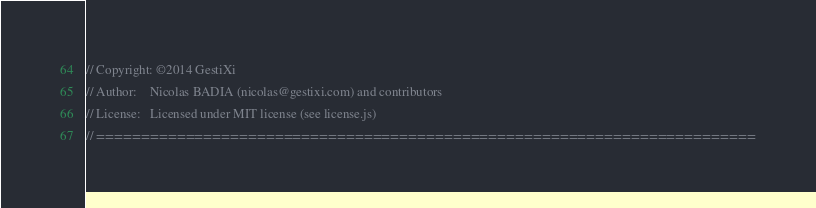Convert code to text. <code><loc_0><loc_0><loc_500><loc_500><_JavaScript_>// Copyright: ©2014 GestiXi
// Author:    Nicolas BADIA (nicolas@gestixi.com) and contributors
// License:   Licensed under MIT license (see license.js)
// ==========================================================================

</code> 